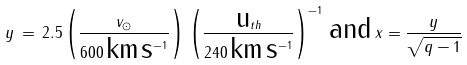<formula> <loc_0><loc_0><loc_500><loc_500>y \, = \, 2 . 5 \left ( \frac { v _ { \odot } } { 6 0 0 \, \text {km} \, \text {s} ^ { - 1 } } \right ) \, \left ( \frac { \text {u} _ { t h } } { 2 4 0 \, \text {km} \, \text {s} ^ { - 1 } } \right ) ^ { - 1 } \, \text {and} \, x = \frac { y } { \sqrt { q - 1 } }</formula> 